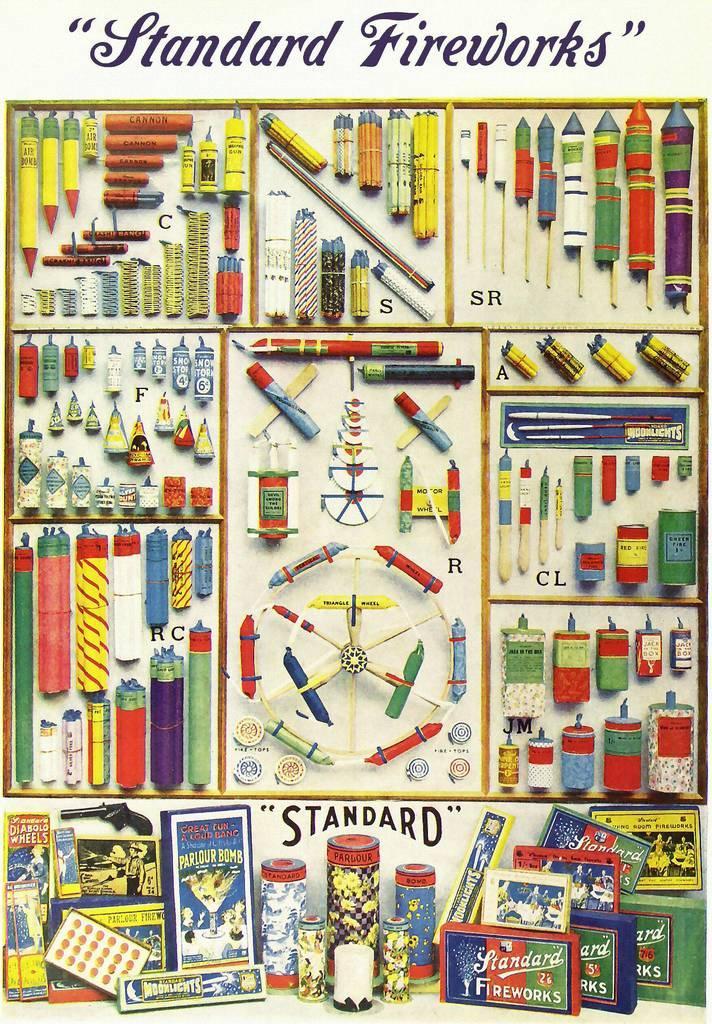<image>
Share a concise interpretation of the image provided. Standard is the brand of fireworks being solicited. 